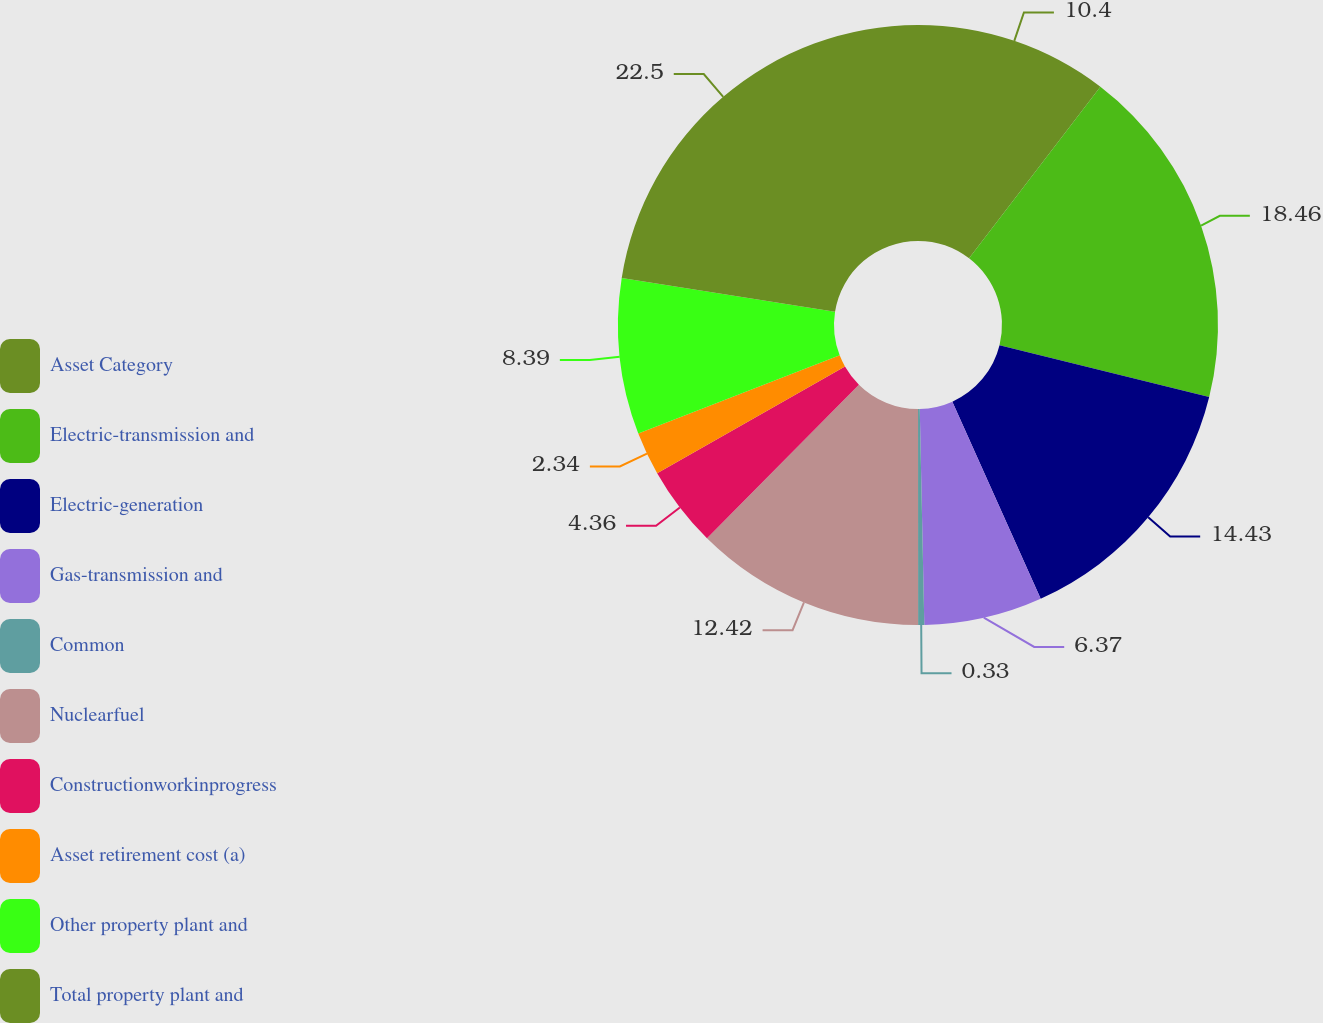Convert chart to OTSL. <chart><loc_0><loc_0><loc_500><loc_500><pie_chart><fcel>Asset Category<fcel>Electric-transmission and<fcel>Electric-generation<fcel>Gas-transmission and<fcel>Common<fcel>Nuclearfuel<fcel>Constructionworkinprogress<fcel>Asset retirement cost (a)<fcel>Other property plant and<fcel>Total property plant and<nl><fcel>10.4%<fcel>18.46%<fcel>14.43%<fcel>6.37%<fcel>0.33%<fcel>12.42%<fcel>4.36%<fcel>2.34%<fcel>8.39%<fcel>22.49%<nl></chart> 